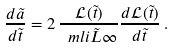<formula> <loc_0><loc_0><loc_500><loc_500>\frac { d \tilde { a } } { d \tilde { t } } = 2 \, \frac { \mathcal { L } ( \tilde { t } ) } { \ m l i { \tilde { L } } { \infty } } \frac { d \mathcal { L } ( \tilde { t } ) } { d \tilde { t } } \, .</formula> 